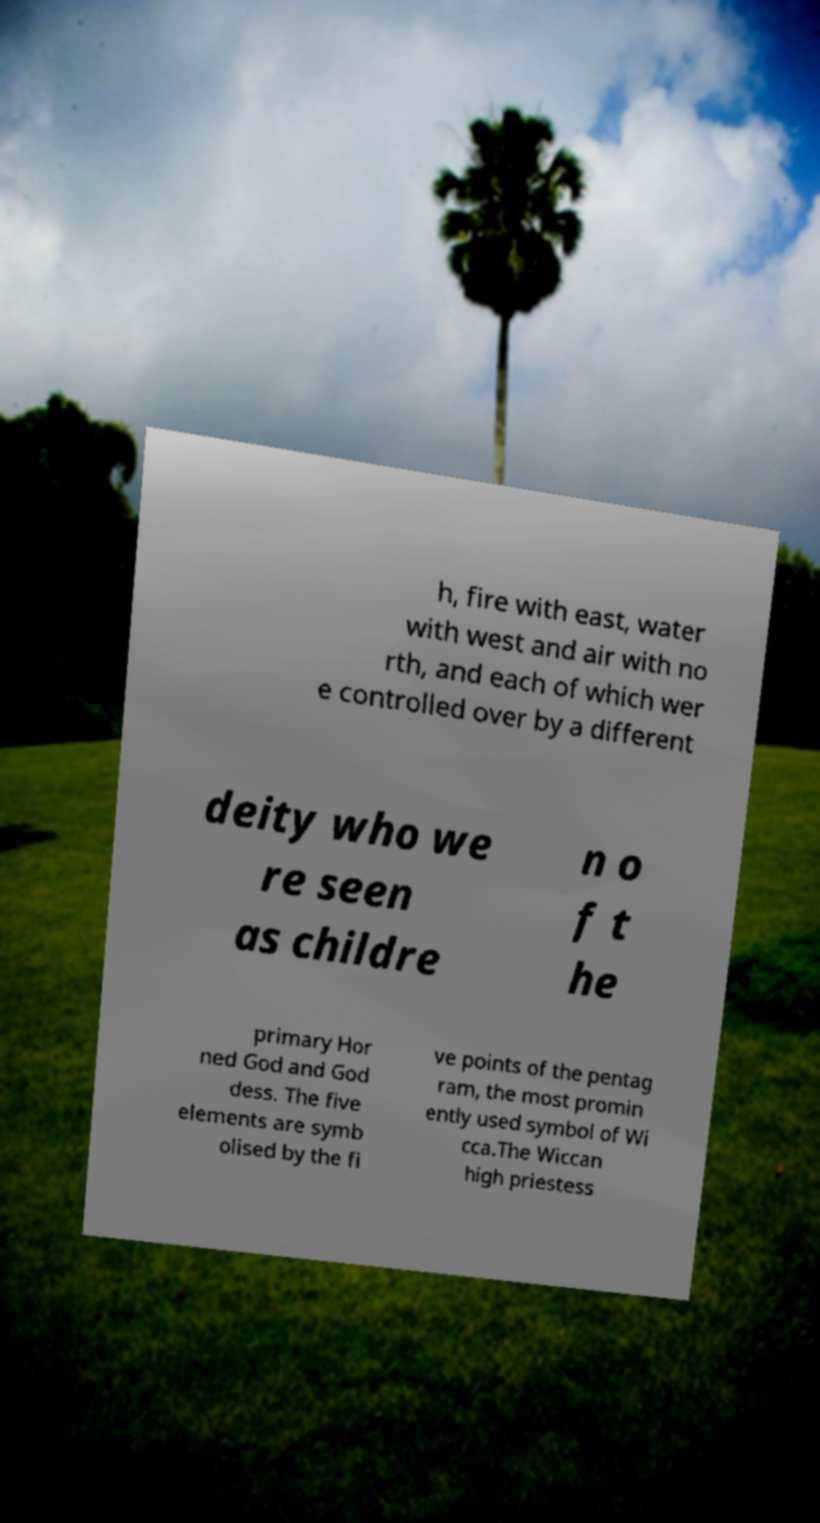There's text embedded in this image that I need extracted. Can you transcribe it verbatim? h, fire with east, water with west and air with no rth, and each of which wer e controlled over by a different deity who we re seen as childre n o f t he primary Hor ned God and God dess. The five elements are symb olised by the fi ve points of the pentag ram, the most promin ently used symbol of Wi cca.The Wiccan high priestess 